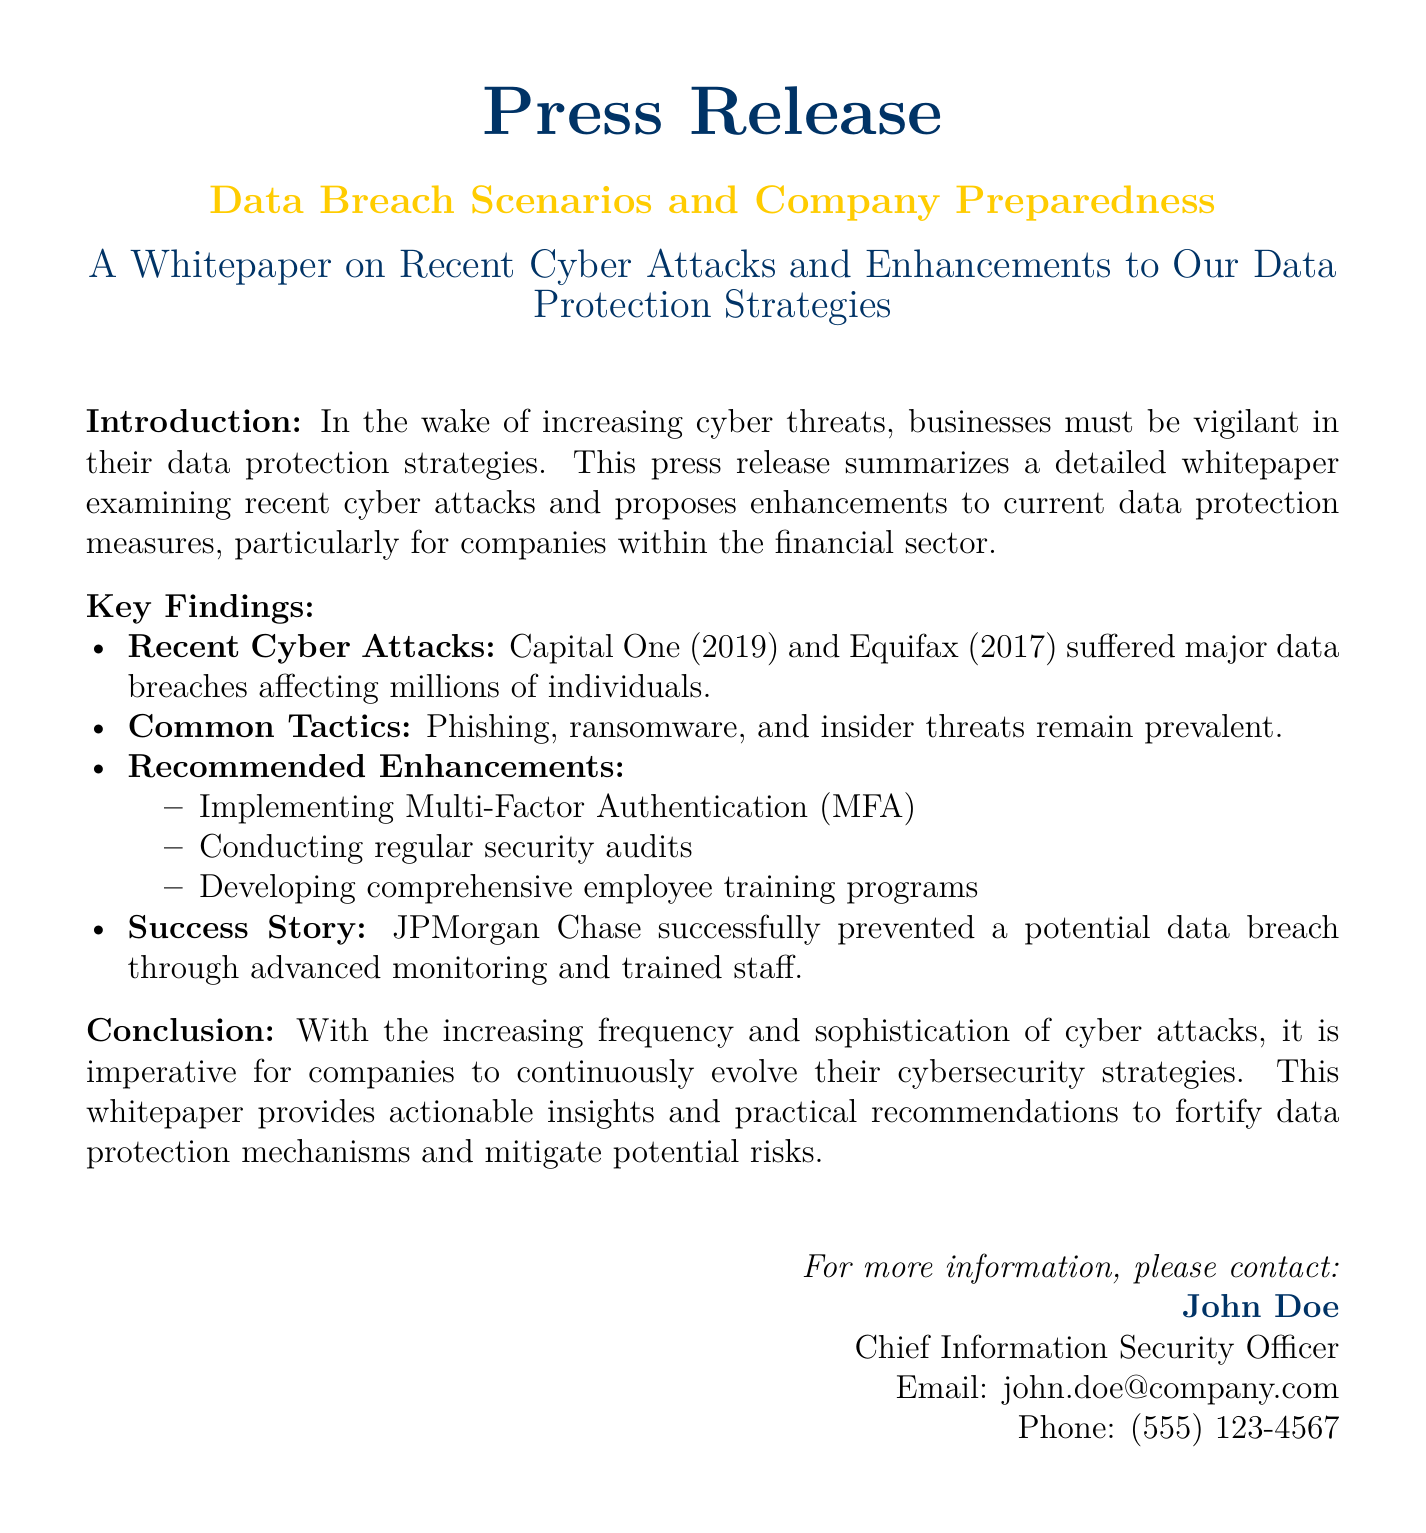what is the title of the whitepaper? The title of the whitepaper is found in the document's header and is "Data Breach Scenarios and Company Preparedness."
Answer: Data Breach Scenarios and Company Preparedness what year did Capital One experience a data breach? The year of the Capital One data breach is mentioned in the key findings of the document.
Answer: 2019 what is a recommended enhancement to data protection strategies? The document lists several enhancements to data protection strategies, one of which is mentioned explicitly.
Answer: Implementing Multi-Factor Authentication how many major data breaches are mentioned in the key findings? The document illustrates important cases of data breaches and specifies them in the key findings.
Answer: Two which company successfully prevented a data breach? The document provides a success story detailing a specific company that took action to prevent a data breach.
Answer: JPMorgan Chase what type of attacks are considered common according to the document? The document states specific types of cyber attacks that are prevalent and can be found in the key findings section.
Answer: Phishing, ransomware, insider threats who is the Chief Information Security Officer mentioned in the document? The identity of the Chief Information Security Officer is provided in the contact information section of the document.
Answer: John Doe how does the document categorize cyber threats? The document categorizes threats within the key findings and highlights their nature as a significant aspect of data protection.
Answer: Cyber threats what is the primary focus of this whitepaper? The main purpose of the whitepaper is indicated in the introduction of the document.
Answer: Enhancements to data protection strategies 